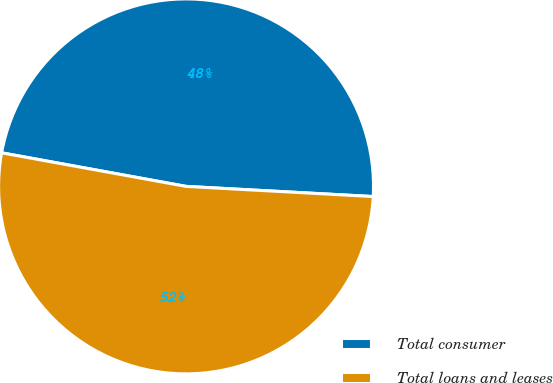Convert chart. <chart><loc_0><loc_0><loc_500><loc_500><pie_chart><fcel>Total consumer<fcel>Total loans and leases<nl><fcel>48.0%<fcel>52.0%<nl></chart> 